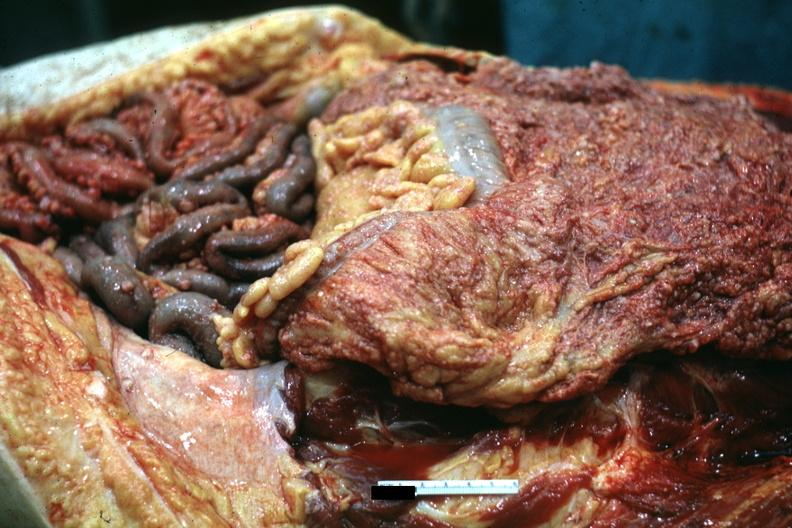what is present?
Answer the question using a single word or phrase. Peritoneum 